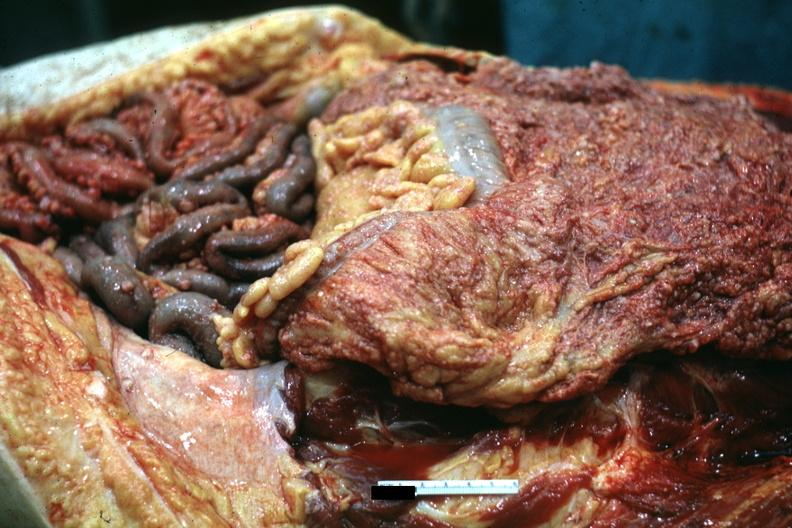what is present?
Answer the question using a single word or phrase. Peritoneum 